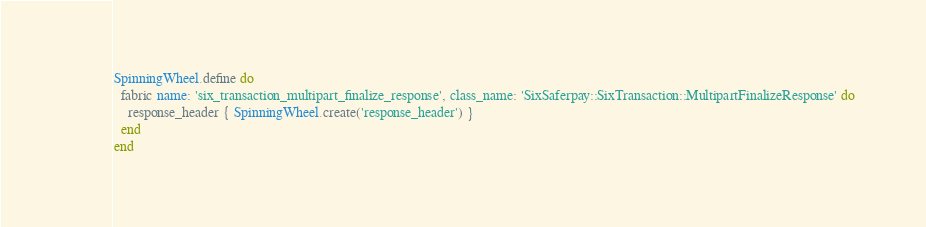Convert code to text. <code><loc_0><loc_0><loc_500><loc_500><_Ruby_>SpinningWheel.define do
  fabric name: 'six_transaction_multipart_finalize_response', class_name: 'SixSaferpay::SixTransaction::MultipartFinalizeResponse' do
    response_header { SpinningWheel.create('response_header') }
  end
end
</code> 